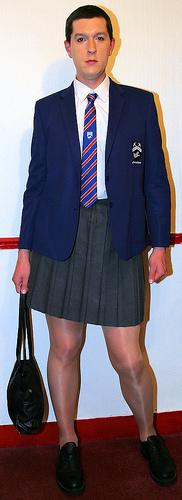Question: what kind of bottoms is the man wearing?
Choices:
A. Pants.
B. Jeans.
C. Shorts.
D. A skirt.
Answer with the letter. Answer: D 